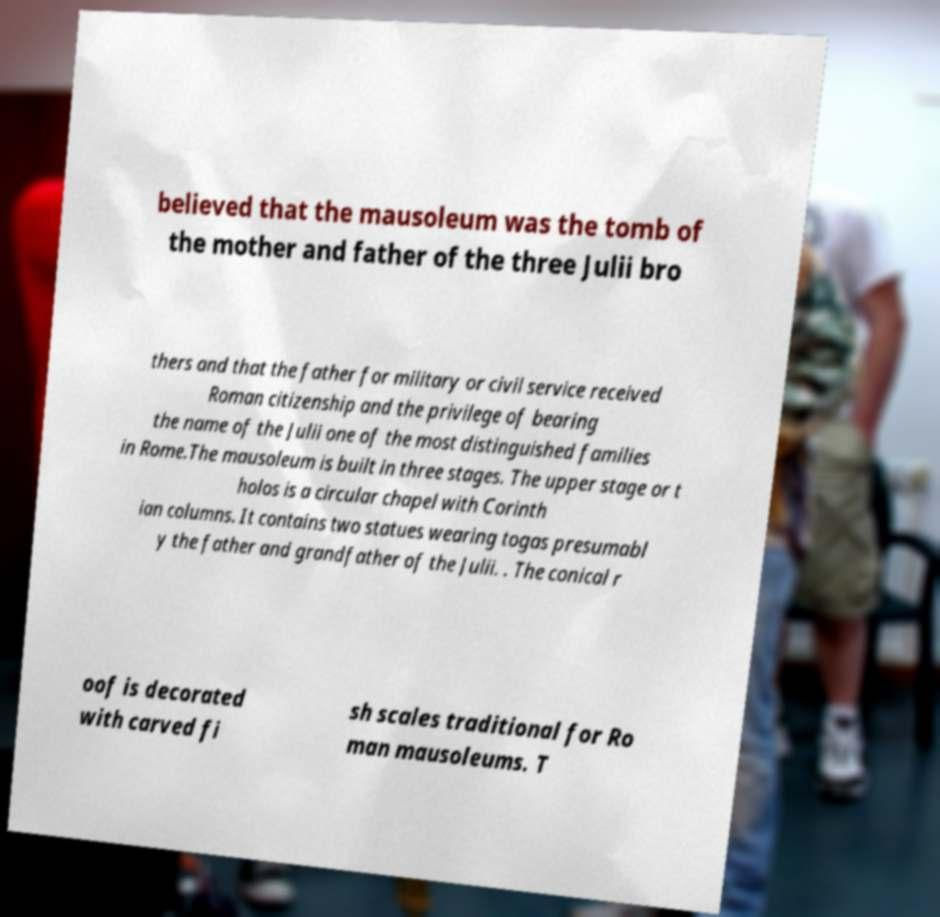I need the written content from this picture converted into text. Can you do that? believed that the mausoleum was the tomb of the mother and father of the three Julii bro thers and that the father for military or civil service received Roman citizenship and the privilege of bearing the name of the Julii one of the most distinguished families in Rome.The mausoleum is built in three stages. The upper stage or t holos is a circular chapel with Corinth ian columns. It contains two statues wearing togas presumabl y the father and grandfather of the Julii. . The conical r oof is decorated with carved fi sh scales traditional for Ro man mausoleums. T 